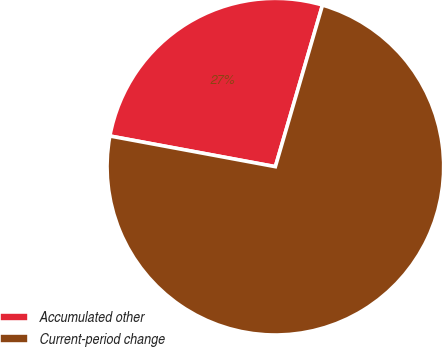<chart> <loc_0><loc_0><loc_500><loc_500><pie_chart><fcel>Accumulated other<fcel>Current-period change<nl><fcel>26.6%<fcel>73.4%<nl></chart> 